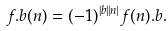Convert formula to latex. <formula><loc_0><loc_0><loc_500><loc_500>f . b ( n ) = ( - 1 ) ^ { | b | | n | } f ( n ) . b .</formula> 